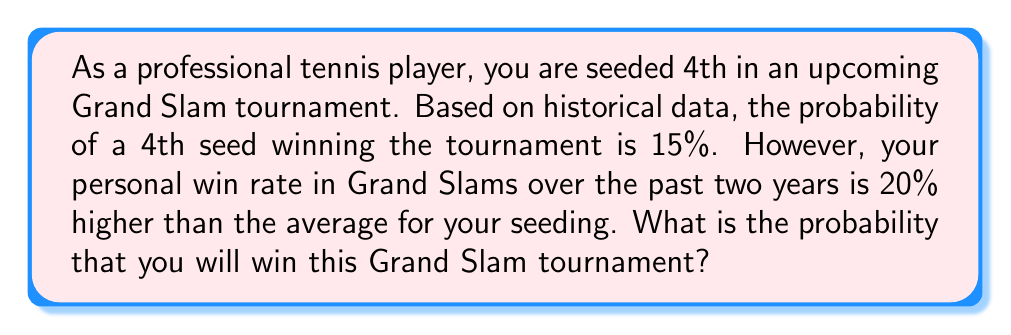Solve this math problem. To solve this problem, we need to follow these steps:

1. Understand the given information:
   - Base probability for a 4th seed to win: 15%
   - Your personal performance is 20% better than average

2. Calculate the increase in probability due to your personal performance:
   Let $x$ be the increase in probability.
   $$x = 15\% \times 20\% = 3\%$$

3. Add this increase to the base probability:
   $$\text{Your probability} = 15\% + 3\% = 18\%$$

4. Convert the percentage to a decimal:
   $$18\% = \frac{18}{100} = 0.18$$

Therefore, your probability of winning the Grand Slam tournament is 0.18 or 18%.
Answer: 0.18 or 18% 